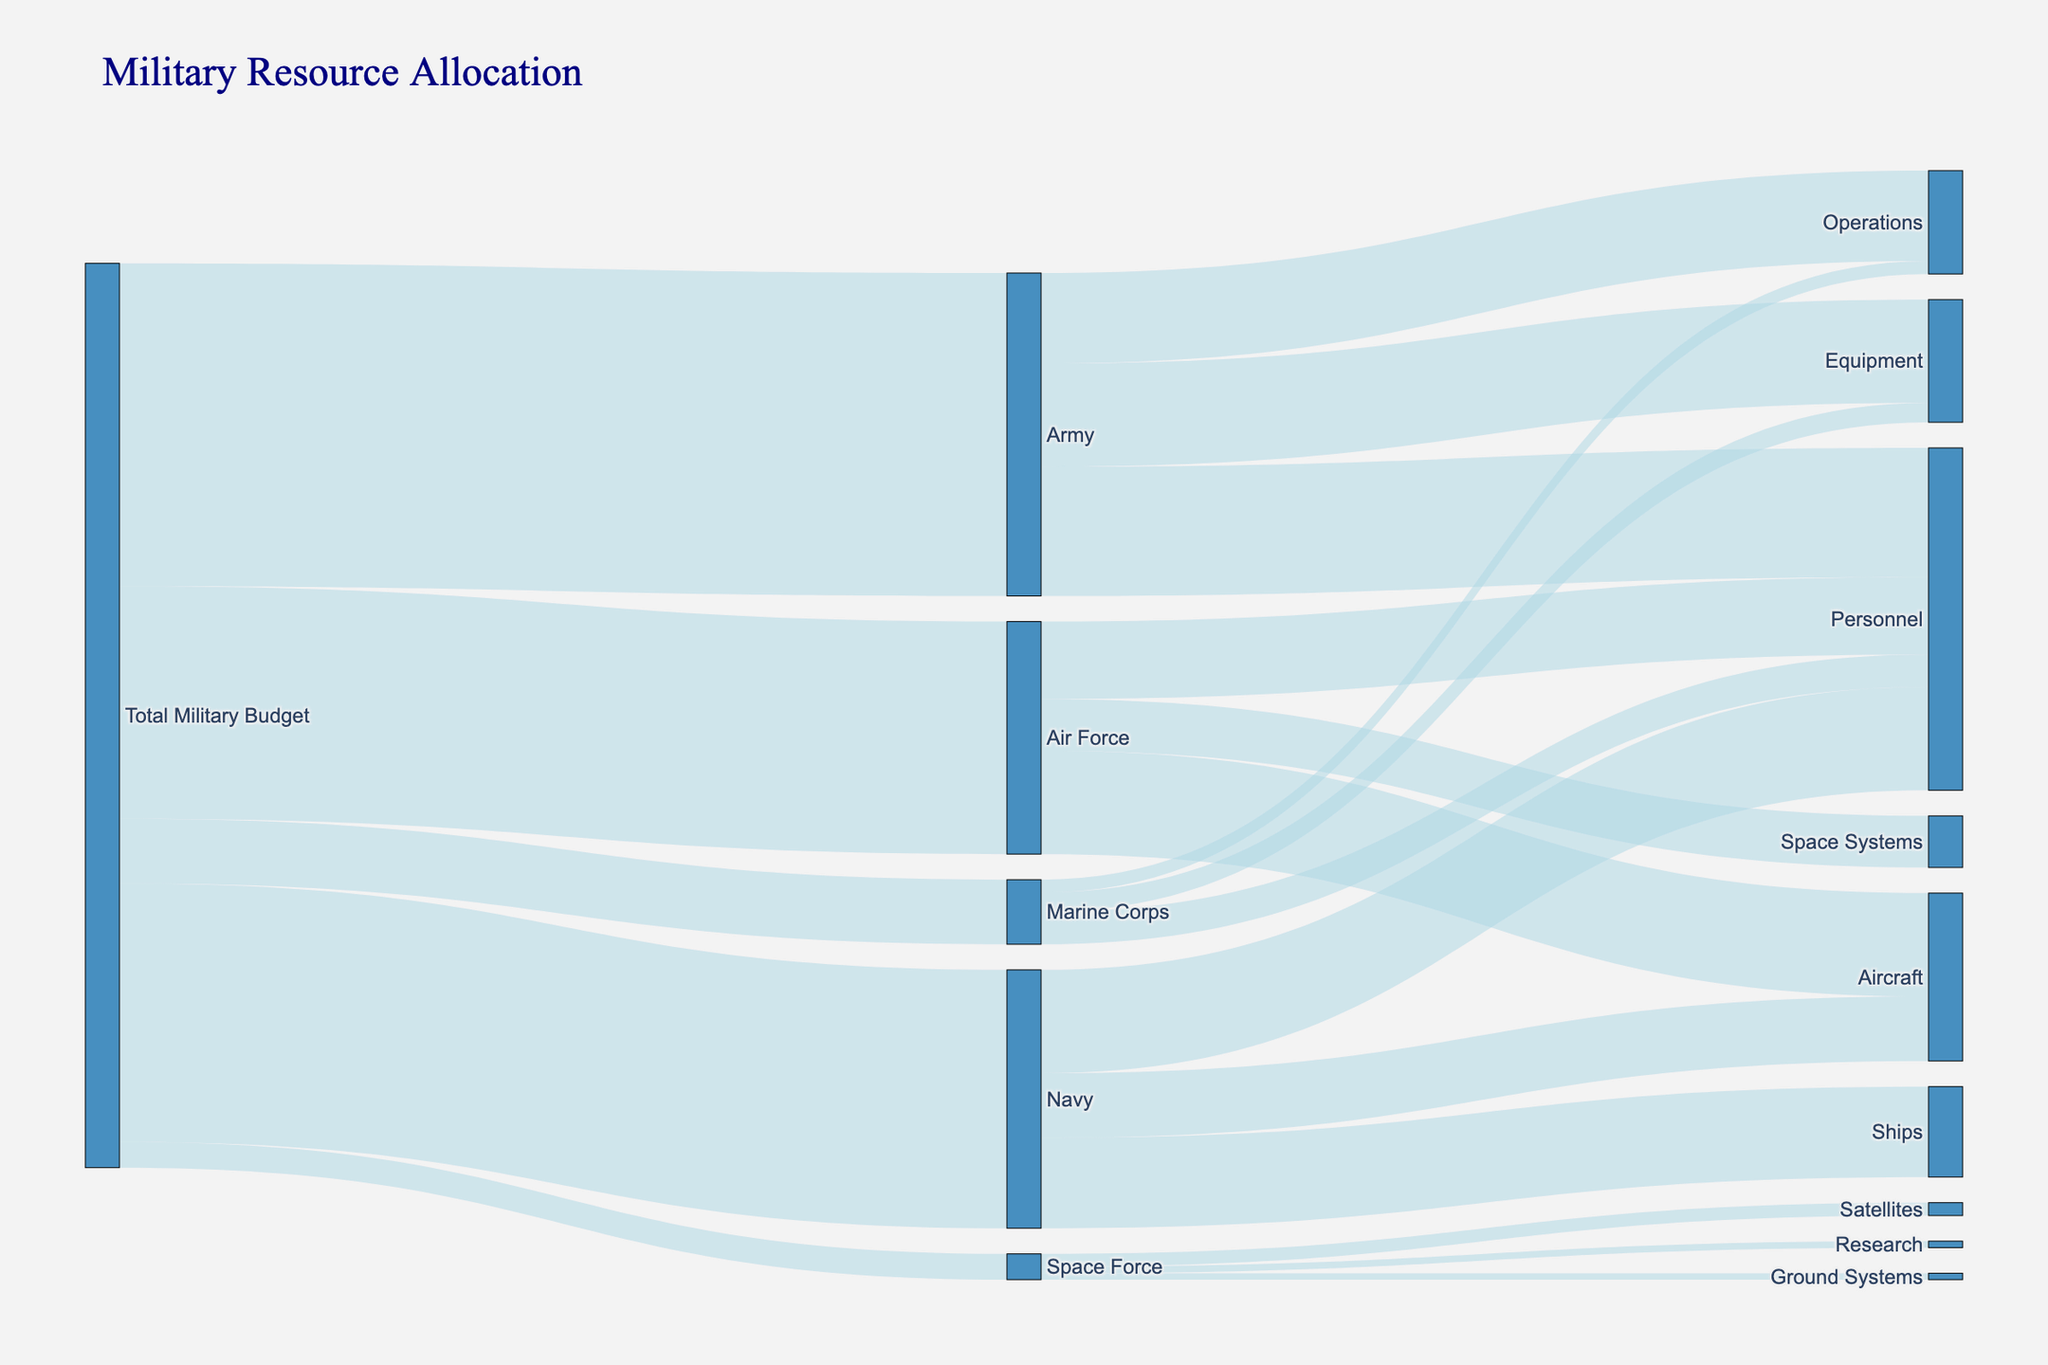What is the total budget allocated to the Navy? The figure shows different budget allocations from the total military budget. The Navy receives one of these allocations. Looking at the connection from "Total Military Budget" to “Navy,” the value is listed.
Answer: 200 billion How much of the Army's budget is allocated to Equipment? In the diagram, each branch of the military shows further allocation to different categories. For the Army, follow the flow to "Equipment" and note the value.
Answer: 80 billion Which branch has the smallest budget allocation? Compare the budget allocations from the "Total Military Budget" to each branch: Army, Navy, Air Force, Marine Corps, and Space Force. Identify the branch with the smallest value.
Answer: Space Force How does the allocation to Marine Corps operations compare to Army operations? Look at the flow from each branch to operations. Note the values for Marine Corps operations and Army operations and compare them directly.
Answer: Marine Corps operations receive less funding than Army operations What is the combined budget for Navy Aircraft and Ships? Look at the budget allocations within the Navy for Aircraft and Ships and sum the values: 50 billion (Aircraft) + 70 billion (Ships).
Answer: 120 billion What is the largest single allocation within the Air Force? Analyze the different allocations from the Air Force: Personnel, Aircraft, and Space Systems. Identify the largest value.
Answer: Aircraft How much is allocated to Space Force Satellites compared to Ground Systems? Check the allocations within the Space Force to Satellites and Ground Systems and compare the values directly.
Answer: Satellites receive more than Ground Systems What percentage of the total military budget is allocated to Personnel in all branches? Calculate the total amount allocated to Personnel by summing the values across all branches and then divide by the total military budget: (100 billion + 80 billion + 60 billion + 25 billion) / 700 billion. Multiply by 100 to get the percentage.
Answer: ~ 37.86% How much higher is the allocation to Army Equipment compared to Marine Corps Equipment? Look at the values for Army Equipment and Marine Corps Equipment and find the difference: 80 billion (Army Equipment) - 15 billion (Marine Corps Equipment).
Answer: 65 billion Which category within the Navy has the second-highest allocation? Examine the allocations within the Navy to Personnel, Ships, and Aircraft. Identify the second-largest value.
Answer: Ships 